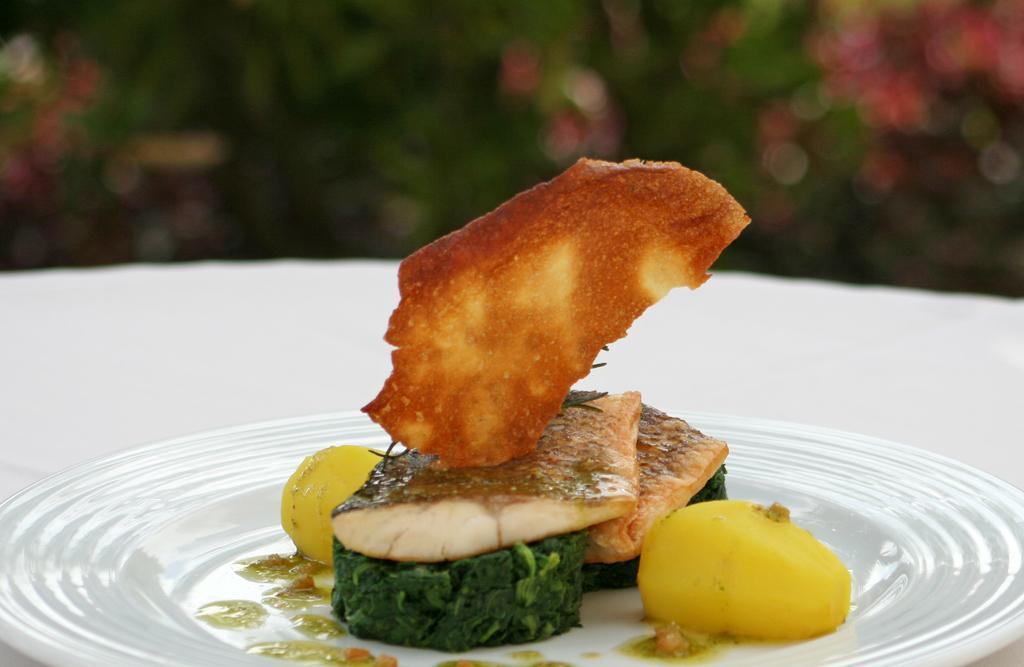Can you describe this image briefly? In this picture we can see food in the plate, and we can see blurry background. 